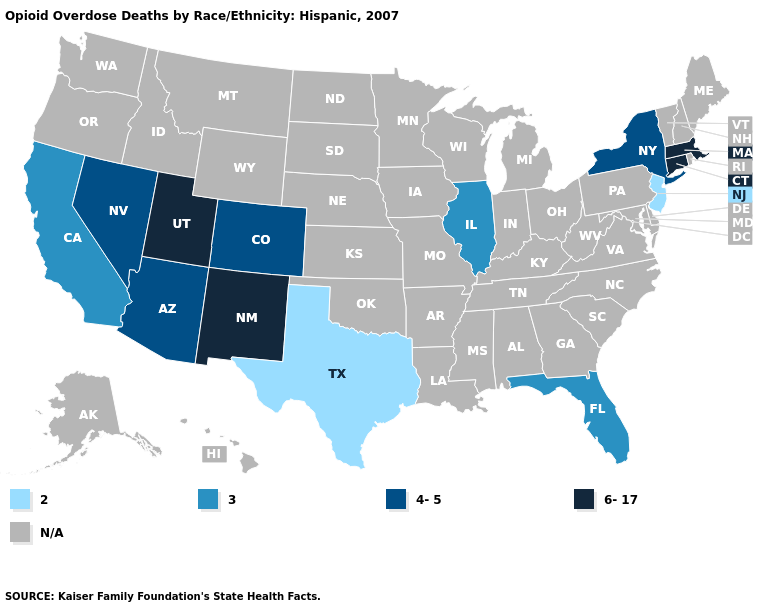Which states have the lowest value in the South?
Give a very brief answer. Texas. Name the states that have a value in the range N/A?
Answer briefly. Alabama, Alaska, Arkansas, Delaware, Georgia, Hawaii, Idaho, Indiana, Iowa, Kansas, Kentucky, Louisiana, Maine, Maryland, Michigan, Minnesota, Mississippi, Missouri, Montana, Nebraska, New Hampshire, North Carolina, North Dakota, Ohio, Oklahoma, Oregon, Pennsylvania, Rhode Island, South Carolina, South Dakota, Tennessee, Vermont, Virginia, Washington, West Virginia, Wisconsin, Wyoming. What is the value of Idaho?
Keep it brief. N/A. What is the lowest value in states that border California?
Be succinct. 4-5. What is the highest value in the USA?
Keep it brief. 6-17. Name the states that have a value in the range 4-5?
Give a very brief answer. Arizona, Colorado, Nevada, New York. What is the lowest value in the Northeast?
Be succinct. 2. Among the states that border Utah , which have the lowest value?
Quick response, please. Arizona, Colorado, Nevada. Does Florida have the lowest value in the South?
Give a very brief answer. No. Does the first symbol in the legend represent the smallest category?
Keep it brief. Yes. What is the lowest value in states that border Texas?
Answer briefly. 6-17. Among the states that border Delaware , which have the lowest value?
Short answer required. New Jersey. How many symbols are there in the legend?
Answer briefly. 5. What is the value of Missouri?
Answer briefly. N/A. 